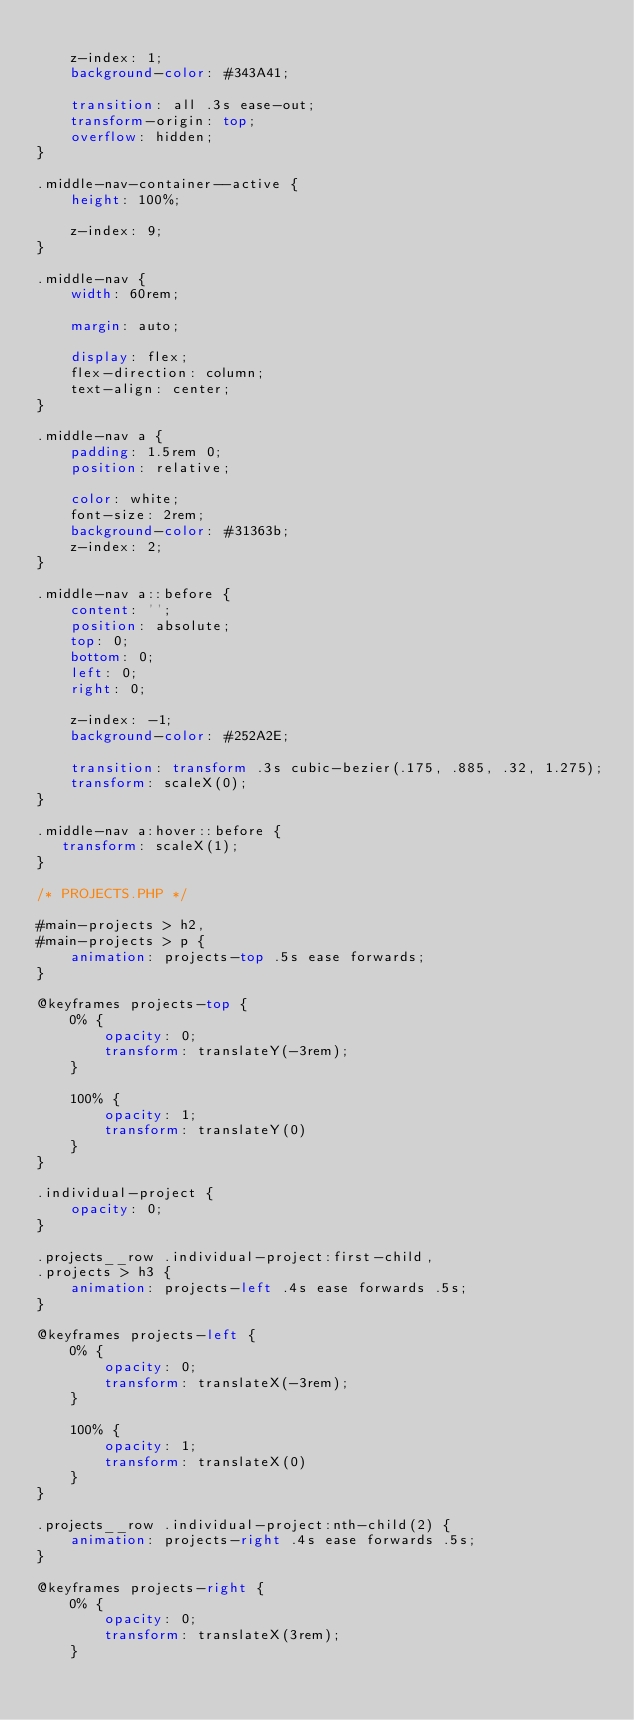Convert code to text. <code><loc_0><loc_0><loc_500><loc_500><_CSS_>    
    z-index: 1;
    background-color: #343A41;

    transition: all .3s ease-out;
    transform-origin: top;
    overflow: hidden;
}

.middle-nav-container--active {
    height: 100%;

    z-index: 9;
}

.middle-nav {
    width: 60rem;

    margin: auto;

    display: flex;
    flex-direction: column;
    text-align: center;
}

.middle-nav a {
    padding: 1.5rem 0;
    position: relative;

    color: white;
    font-size: 2rem;   
    background-color: #31363b;
    z-index: 2;
}

.middle-nav a::before {
    content: '';
    position: absolute;
    top: 0;
    bottom: 0;
    left: 0;
    right: 0;

    z-index: -1;
    background-color: #252A2E;

    transition: transform .3s cubic-bezier(.175, .885, .32, 1.275);
    transform: scaleX(0);
}

.middle-nav a:hover::before {
   transform: scaleX(1);
}

/* PROJECTS.PHP */

#main-projects > h2,
#main-projects > p {
    animation: projects-top .5s ease forwards;
}

@keyframes projects-top {
    0% {
        opacity: 0;
        transform: translateY(-3rem);
    }

    100% {
        opacity: 1;
        transform: translateY(0)
    }
}

.individual-project {
    opacity: 0;
}

.projects__row .individual-project:first-child,
.projects > h3 {
    animation: projects-left .4s ease forwards .5s;
}

@keyframes projects-left {
    0% {
        opacity: 0;
        transform: translateX(-3rem);
    }

    100% {
        opacity: 1;
        transform: translateX(0)
    }
}

.projects__row .individual-project:nth-child(2) {
    animation: projects-right .4s ease forwards .5s;
}

@keyframes projects-right {
    0% {
        opacity: 0;
        transform: translateX(3rem);
    }
</code> 